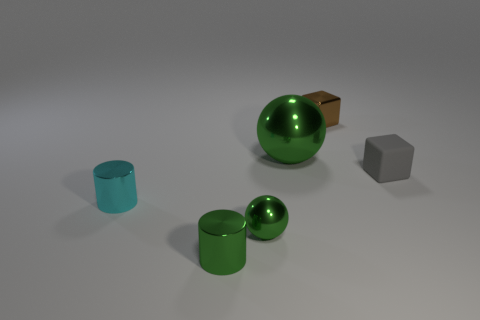What color is the other small thing that is the same shape as the gray thing?
Your answer should be compact. Brown. How many things are both on the right side of the cyan metal cylinder and in front of the tiny gray rubber cube?
Offer a terse response. 2. Is the number of brown cubes that are to the right of the brown metallic thing greater than the number of cubes that are on the left side of the small cyan cylinder?
Offer a terse response. No. What size is the gray matte block?
Offer a terse response. Small. Is there another thing of the same shape as the cyan thing?
Offer a very short reply. Yes. There is a tiny gray thing; does it have the same shape as the green shiny thing that is behind the tiny cyan thing?
Provide a short and direct response. No. What size is the object that is on the right side of the big green metal sphere and in front of the brown metal cube?
Keep it short and to the point. Small. How many small gray matte objects are there?
Ensure brevity in your answer.  1. There is a cyan cylinder that is the same size as the gray matte block; what is its material?
Offer a very short reply. Metal. Are there any brown metal things that have the same size as the cyan metal cylinder?
Keep it short and to the point. Yes. 